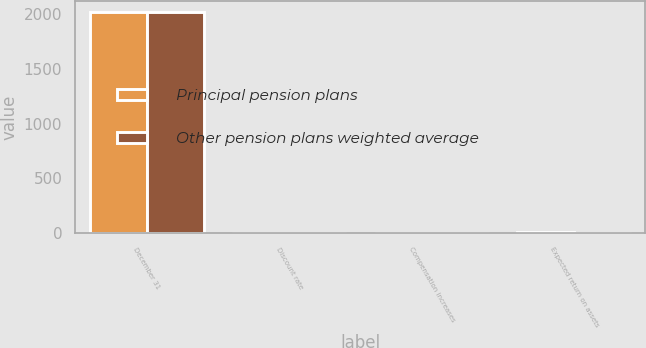Convert chart. <chart><loc_0><loc_0><loc_500><loc_500><stacked_bar_chart><ecel><fcel>December 31<fcel>Discount rate<fcel>Compensation increases<fcel>Expected return on assets<nl><fcel>Principal pension plans<fcel>2013<fcel>4.85<fcel>4<fcel>7.5<nl><fcel>Other pension plans weighted average<fcel>2013<fcel>4.39<fcel>3.76<fcel>6.92<nl></chart> 